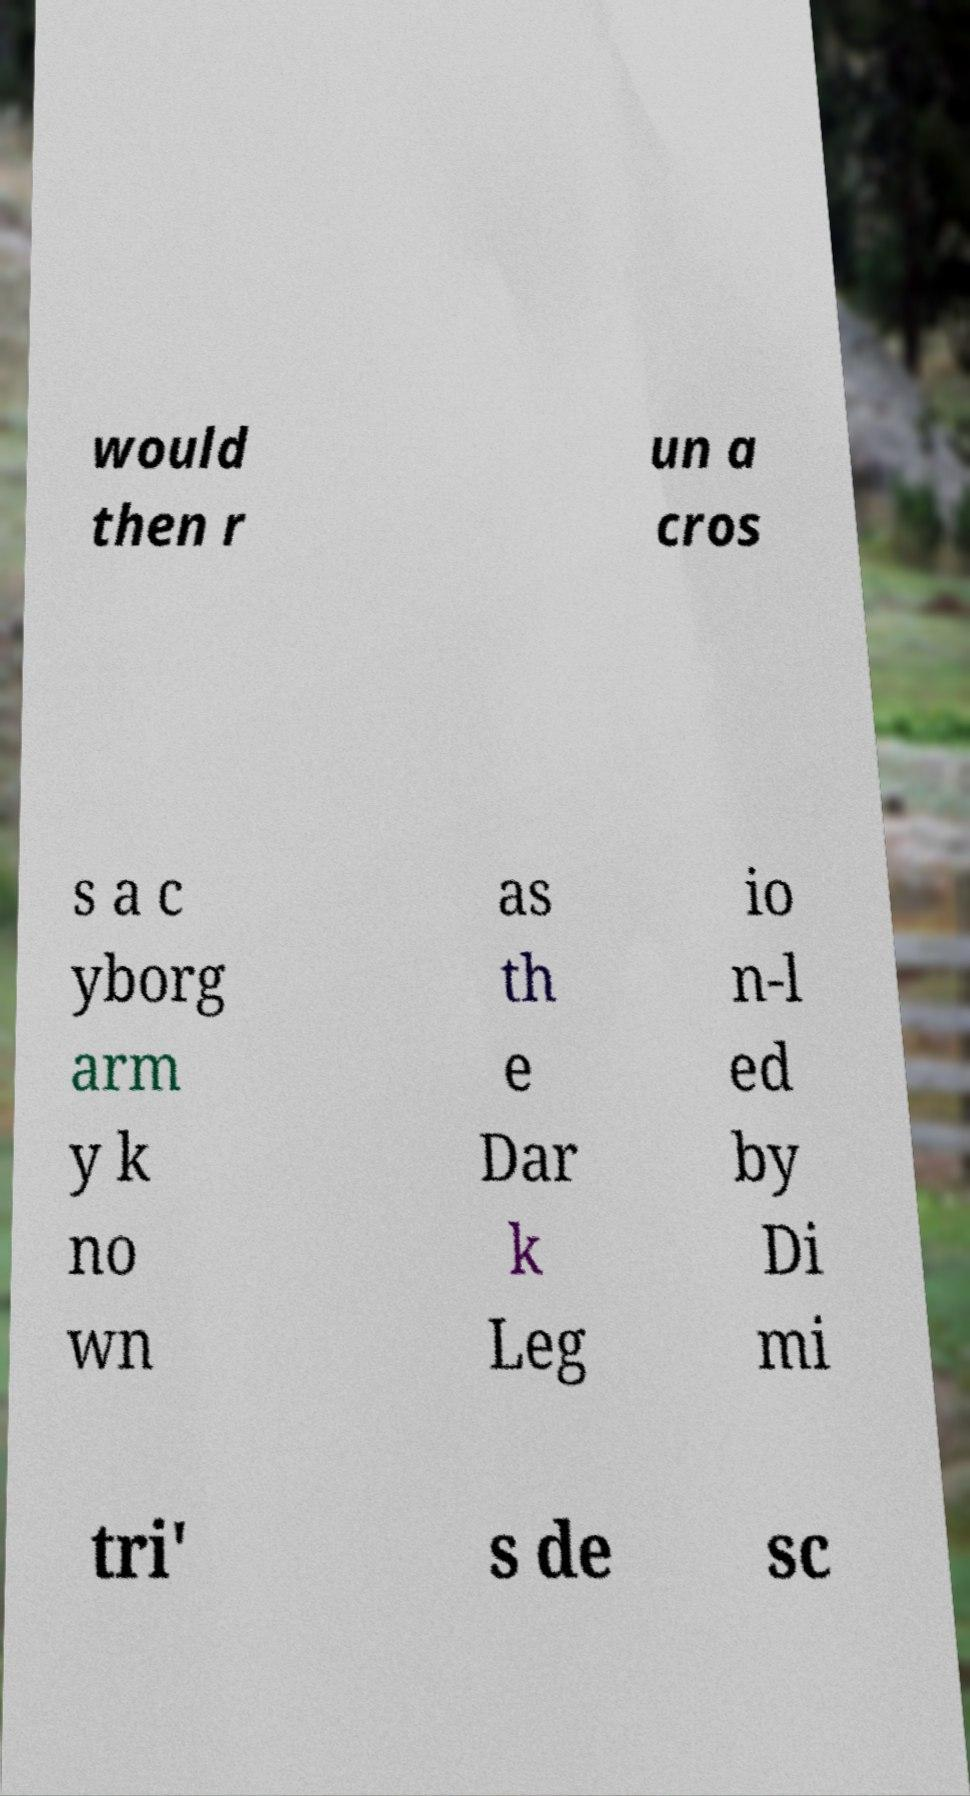I need the written content from this picture converted into text. Can you do that? would then r un a cros s a c yborg arm y k no wn as th e Dar k Leg io n-l ed by Di mi tri' s de sc 